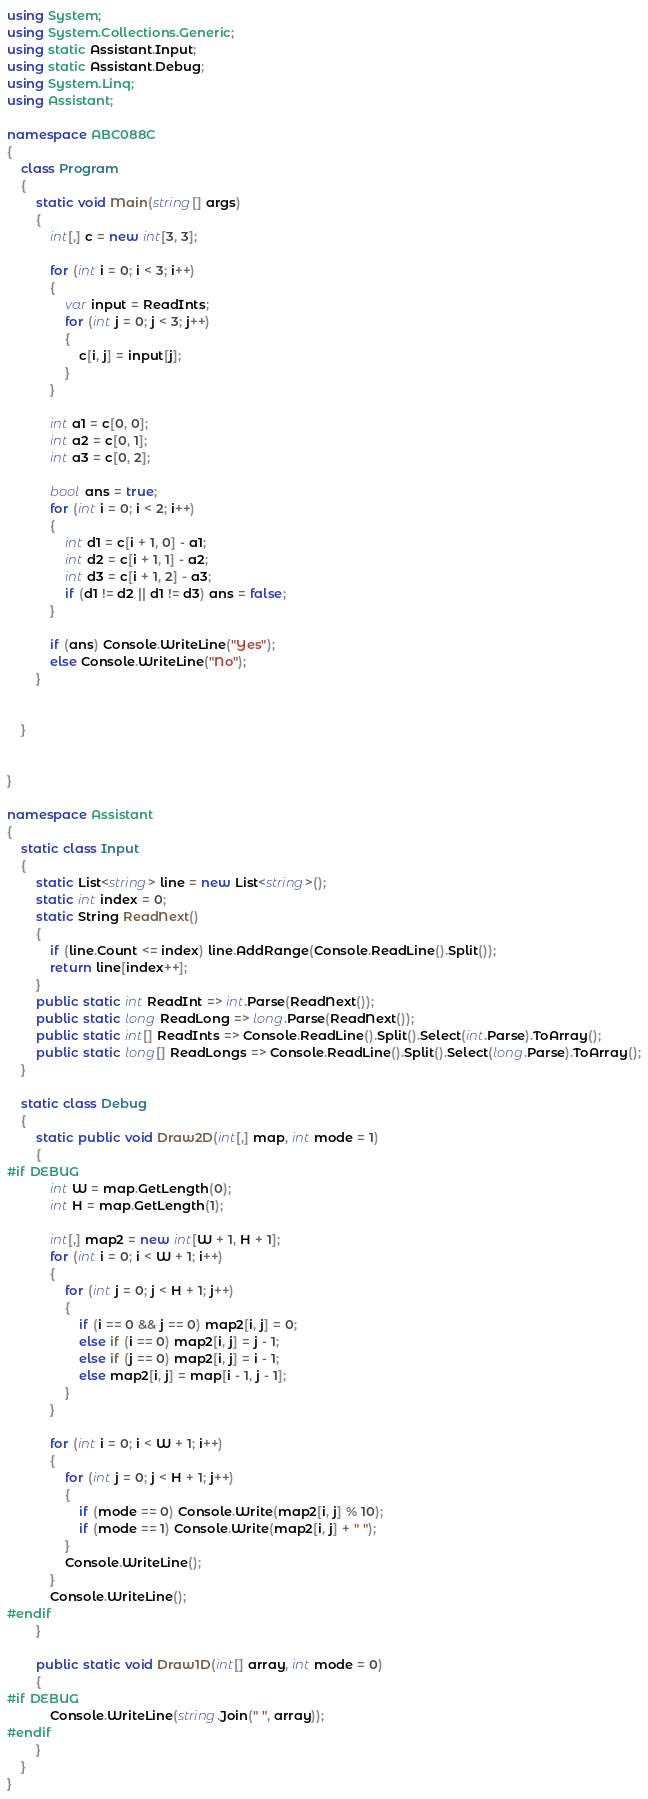Convert code to text. <code><loc_0><loc_0><loc_500><loc_500><_C#_>using System;
using System.Collections.Generic;
using static Assistant.Input;
using static Assistant.Debug;
using System.Linq;
using Assistant;

namespace ABC088C
{
    class Program
    {
        static void Main(string[] args)
        {
            int[,] c = new int[3, 3];

            for (int i = 0; i < 3; i++)
            {
                var input = ReadInts;
                for (int j = 0; j < 3; j++)
                {
                    c[i, j] = input[j];
                }
            }

            int a1 = c[0, 0];
            int a2 = c[0, 1];
            int a3 = c[0, 2];

            bool ans = true;
            for (int i = 0; i < 2; i++)
            {
                int d1 = c[i + 1, 0] - a1;
                int d2 = c[i + 1, 1] - a2;
                int d3 = c[i + 1, 2] - a3;
                if (d1 != d2 || d1 != d3) ans = false;
            }

            if (ans) Console.WriteLine("Yes");
            else Console.WriteLine("No");
        }


    }


}

namespace Assistant
{
    static class Input
    {
        static List<string> line = new List<string>();
        static int index = 0;
        static String ReadNext()
        {
            if (line.Count <= index) line.AddRange(Console.ReadLine().Split());
            return line[index++];
        }
        public static int ReadInt => int.Parse(ReadNext());
        public static long ReadLong => long.Parse(ReadNext());
        public static int[] ReadInts => Console.ReadLine().Split().Select(int.Parse).ToArray();
        public static long[] ReadLongs => Console.ReadLine().Split().Select(long.Parse).ToArray();
    }

    static class Debug
    {
        static public void Draw2D(int[,] map, int mode = 1)
        {
#if DEBUG
            int W = map.GetLength(0);
            int H = map.GetLength(1);

            int[,] map2 = new int[W + 1, H + 1];
            for (int i = 0; i < W + 1; i++)
            {
                for (int j = 0; j < H + 1; j++)
                {
                    if (i == 0 && j == 0) map2[i, j] = 0;
                    else if (i == 0) map2[i, j] = j - 1;
                    else if (j == 0) map2[i, j] = i - 1;
                    else map2[i, j] = map[i - 1, j - 1];
                }
            }

            for (int i = 0; i < W + 1; i++)
            {
                for (int j = 0; j < H + 1; j++)
                {
                    if (mode == 0) Console.Write(map2[i, j] % 10);
                    if (mode == 1) Console.Write(map2[i, j] + " ");
                }
                Console.WriteLine();
            }
            Console.WriteLine();
#endif
        }

        public static void Draw1D(int[] array, int mode = 0)
        {
#if DEBUG
            Console.WriteLine(string.Join(" ", array));
#endif
        }
    }
}
</code> 